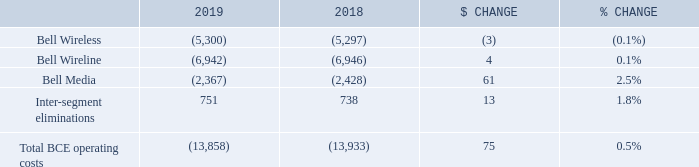4.4 Operating costs
Cost of revenues includes costs of wireless devices and other equipment sold, network and content costs, and payments to other carriers.
Labour costs (net of capitalized costs) include wages, salaries and related taxes and benefits, post-employment benefit plans service cost, and other labour costs, including contractor and outsourcing costs
Other operating costs include marketing, advertising and sales commission costs, bad debt expense, taxes other than income taxes, IT costs, professional service fees and rent
BCE Total BCE operating costs declined by 0.5% in 2019, compared to last year, driven by reduced costs in Bell Media of 2.5%, while costs in Bell Wireless and Bell Wireline remained relatively stable year over year. These results reflected the benefit from the adoption of IFRS 16 in 2019.
What does the cost of revenues include? Cost of revenues includes costs of wireless devices and other equipment sold, network and content costs, and payments to other carriers. What is the percentage change for Bell Wireline? 0.1%. What are the Inter-segment eliminations in 2018? 738. What is the sum of Inter-segment eliminations in 2018 and 2019? 751+738
Answer: 1489. Which segment has the largest $ change? 61 > 4 > |-3|
Answer: bell media. What is the percentage of the costs incurred by Bell Wireline out of the total BCE operating costs in 2019?
Answer scale should be: percent. -6,942/-13,858
Answer: 50.09. 